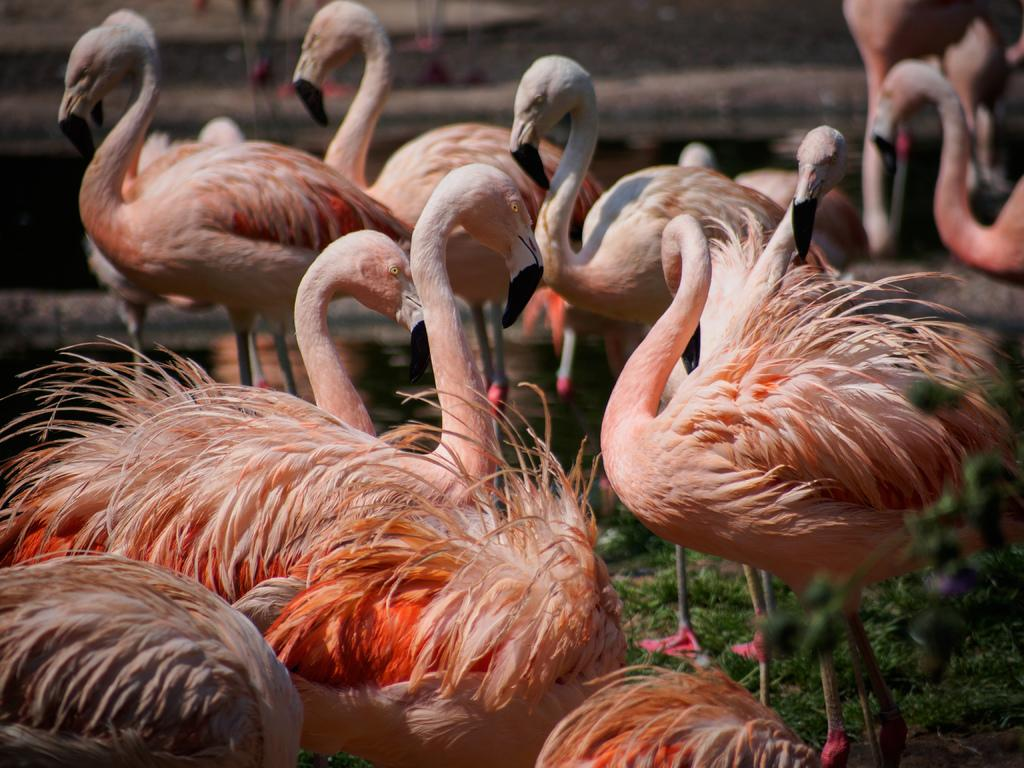What animals can be seen on the ground in the image? There are birds on the ground in the image. Can you describe the background of the image? The background of the image is blurry. Where is the kitten playing with a board in the image? There is no kitten or board present in the image; it features birds on the ground. What type of copy is being made in the image? There is no copying or duplication activity depicted in the image. 